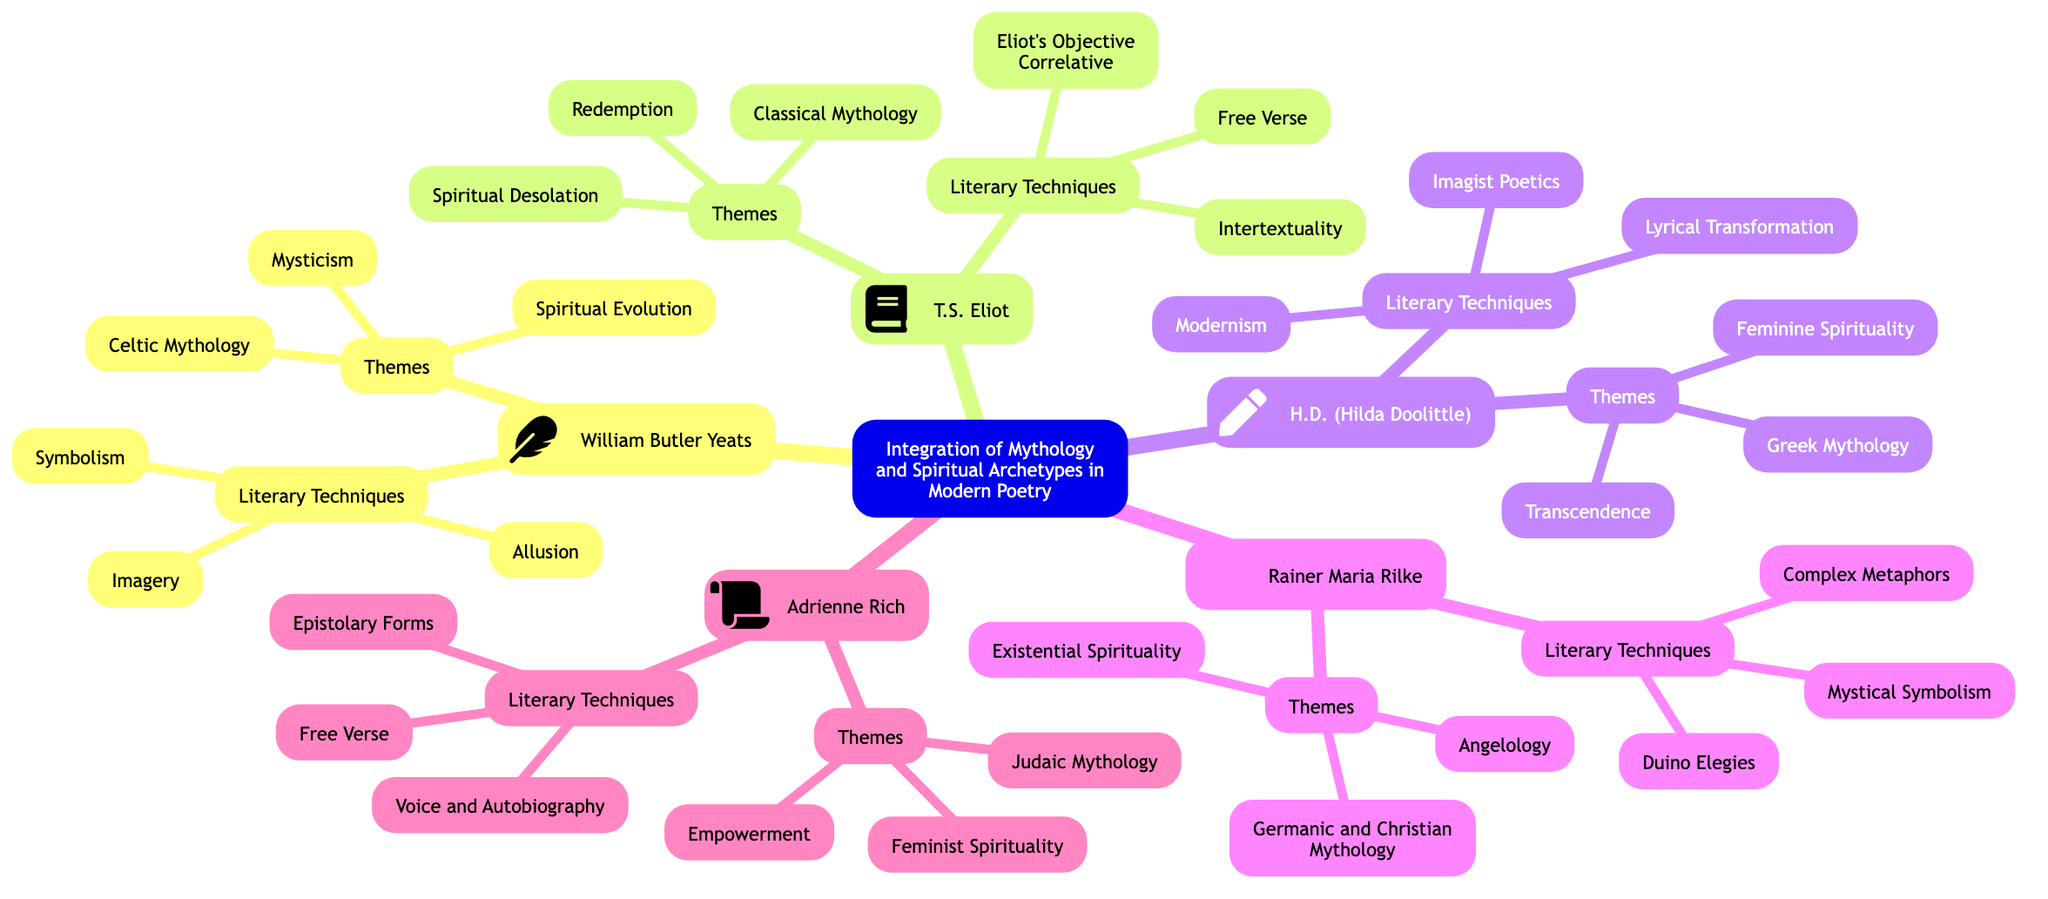What is the main node of the diagram? The main node is clearly labeled at the top and establishes the overall topic of the concept map.
Answer: Integration of Mythology and Spiritual Archetypes in Modern Poetry How many key figures are represented in the diagram? By counting the number of distinct key figure nodes branching out from the main node, I can identify that there are five unique key figures.
Answer: 5 Which key figure is associated with "Feminine Spirituality"? By examining the theme sections under each key figure, I can determine that only H.D. (Hilda Doolittle) is associated with "Feminine Spirituality".
Answer: H.D. (Hilda Doolittle) What literary technique is prominent in T.S. Eliot's work? The literary techniques listed under T.S. Eliot reveal that "Intertextuality" is one of the prominent techniques he employs.
Answer: Intertextuality Which theme is associated with Rainer Maria Rilke? By reviewing the themes associated with Rainer Maria Rilke, I can see multiple themes, with "Angelology" being one of them.
Answer: Angelology What is the relationship between Adrienne Rich and Judaic mythology? From the diagram, Adrienne Rich demonstrates a clear connection by having "Judaic Mythology" listed under her themes, showing that her work incorporates this cultural aspect.
Answer: Adrienne Rich Which key figure utilizes the literary technique called "Imagist Poetics"? By analyzing the literary techniques linked with each key figure, it's evident that "Imagist Poetics" is a technique associated with H.D. (Hilda Doolittle).
Answer: H.D. (Hilda Doolittle) How do the themes of William Butler Yeats connect to spiritual evolution? The theme of "Spiritual Evolution" is directly connected to William Butler Yeats as it is listed among his themes, demonstrating his exploration of this concept within his poetry.
Answer: William Butler Yeats What is the purpose of using "Allusion" in Yeats' poetry? In the context of the diagram, "Allusion" is a literary technique used by Yeats, which serves to refer to or invoke various historical or mythological elements, enriching the spiritual depth of his poetry.
Answer: To enrich spiritual depth 